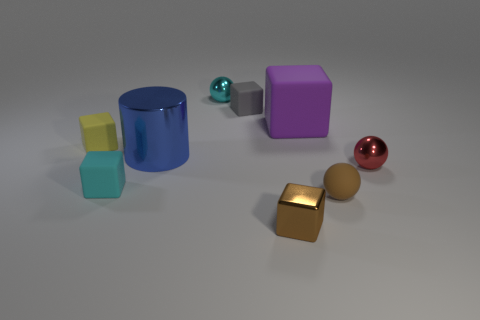Subtract all metallic balls. How many balls are left? 1 Subtract all balls. How many objects are left? 6 Subtract all red balls. How many balls are left? 2 Subtract all brown cylinders. Subtract all gray spheres. How many cylinders are left? 1 Subtract all cyan cylinders. How many purple spheres are left? 0 Subtract all small red balls. Subtract all purple matte blocks. How many objects are left? 7 Add 2 cylinders. How many cylinders are left? 3 Add 7 brown matte objects. How many brown matte objects exist? 8 Subtract 0 red cubes. How many objects are left? 9 Subtract 1 balls. How many balls are left? 2 